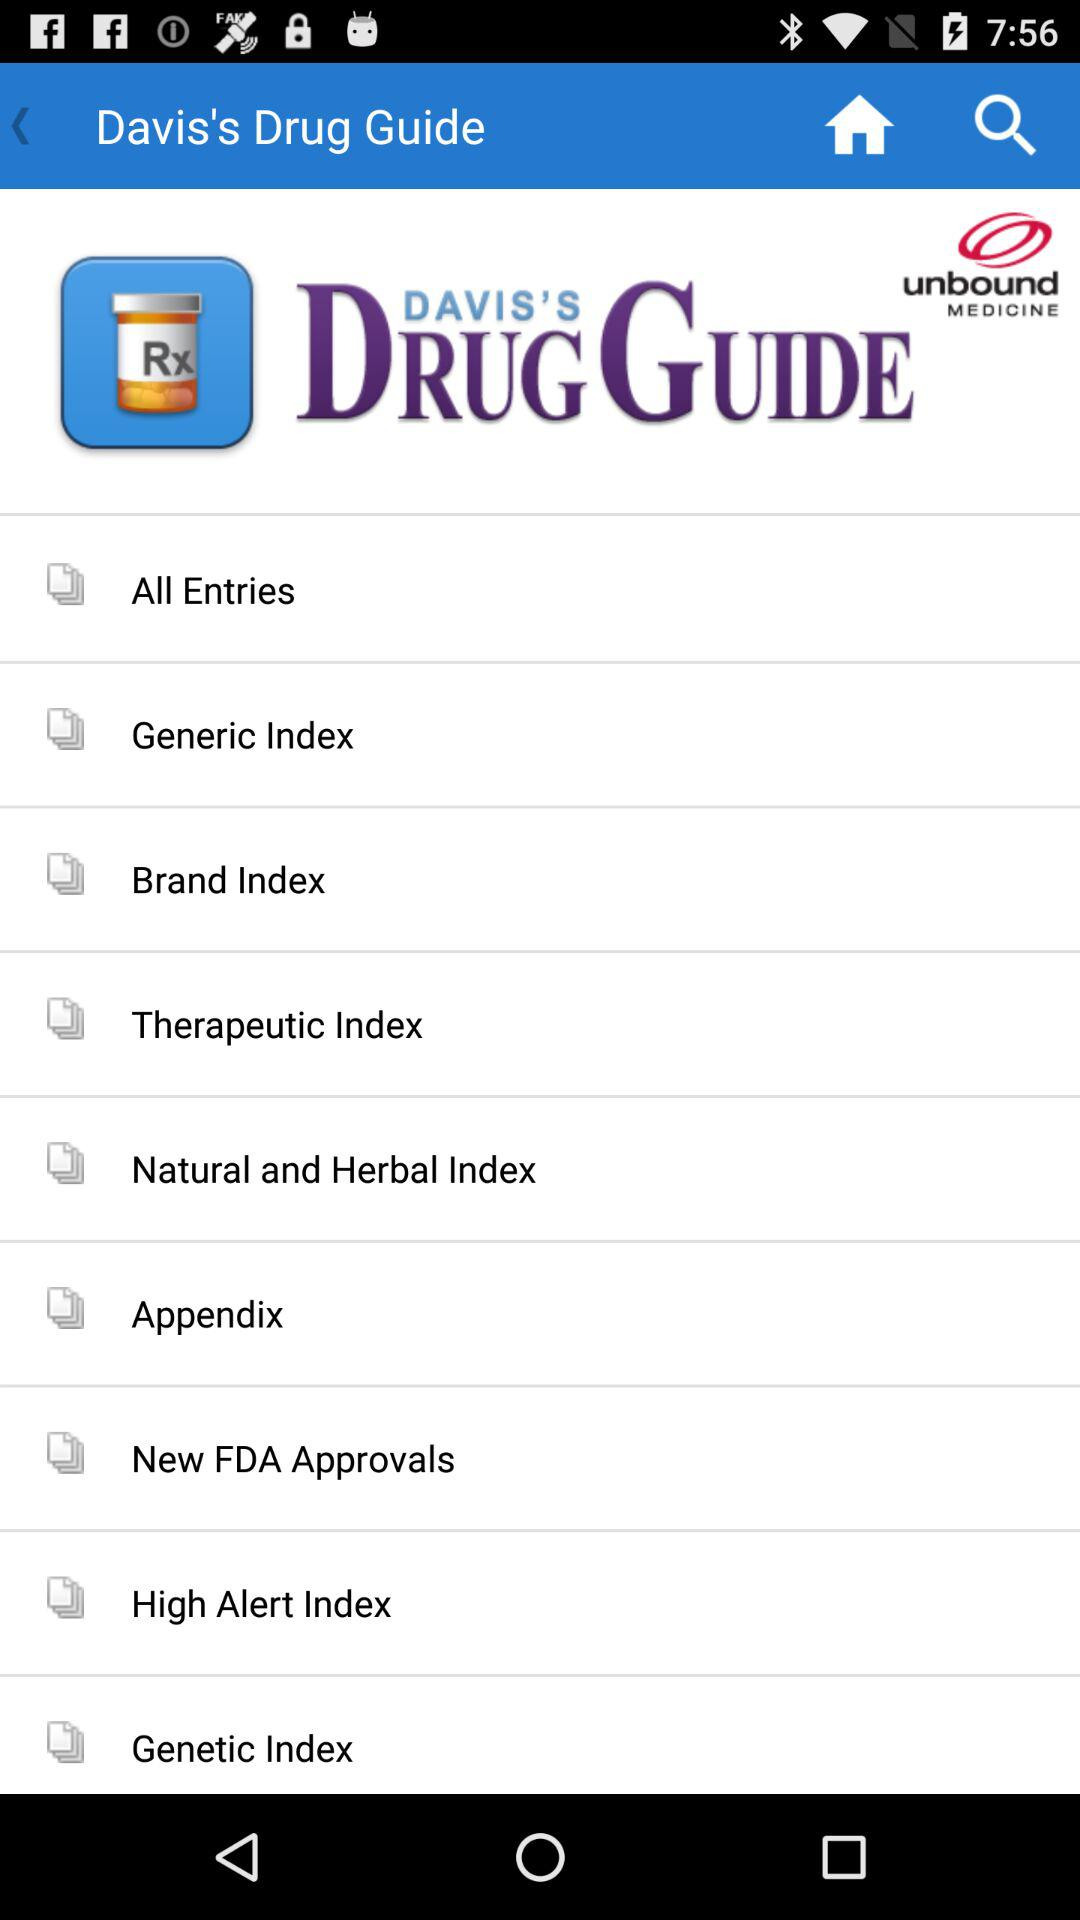What is the application name? The application name is "Davis's Drug Guide". 